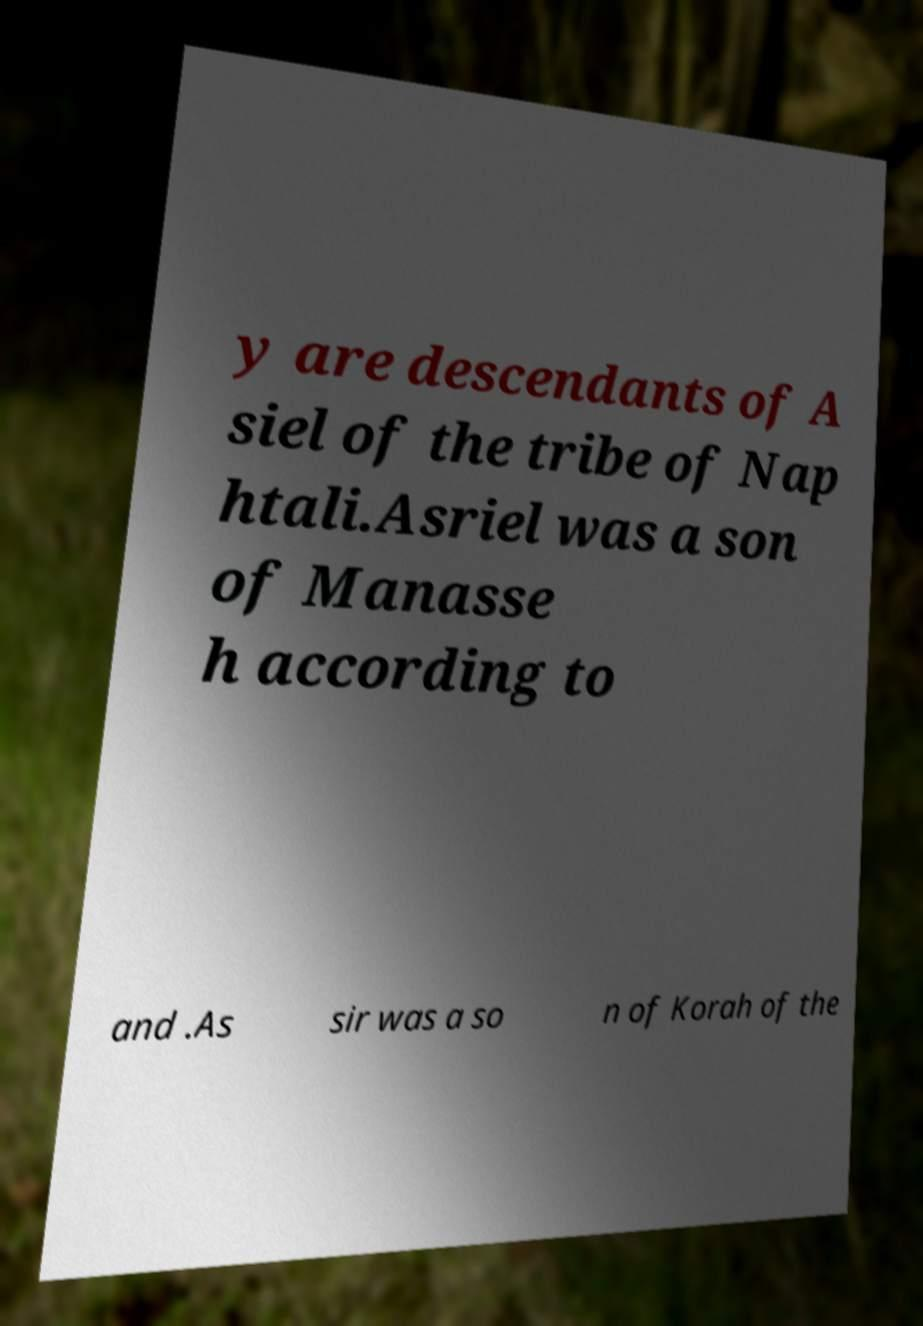I need the written content from this picture converted into text. Can you do that? y are descendants of A siel of the tribe of Nap htali.Asriel was a son of Manasse h according to and .As sir was a so n of Korah of the 